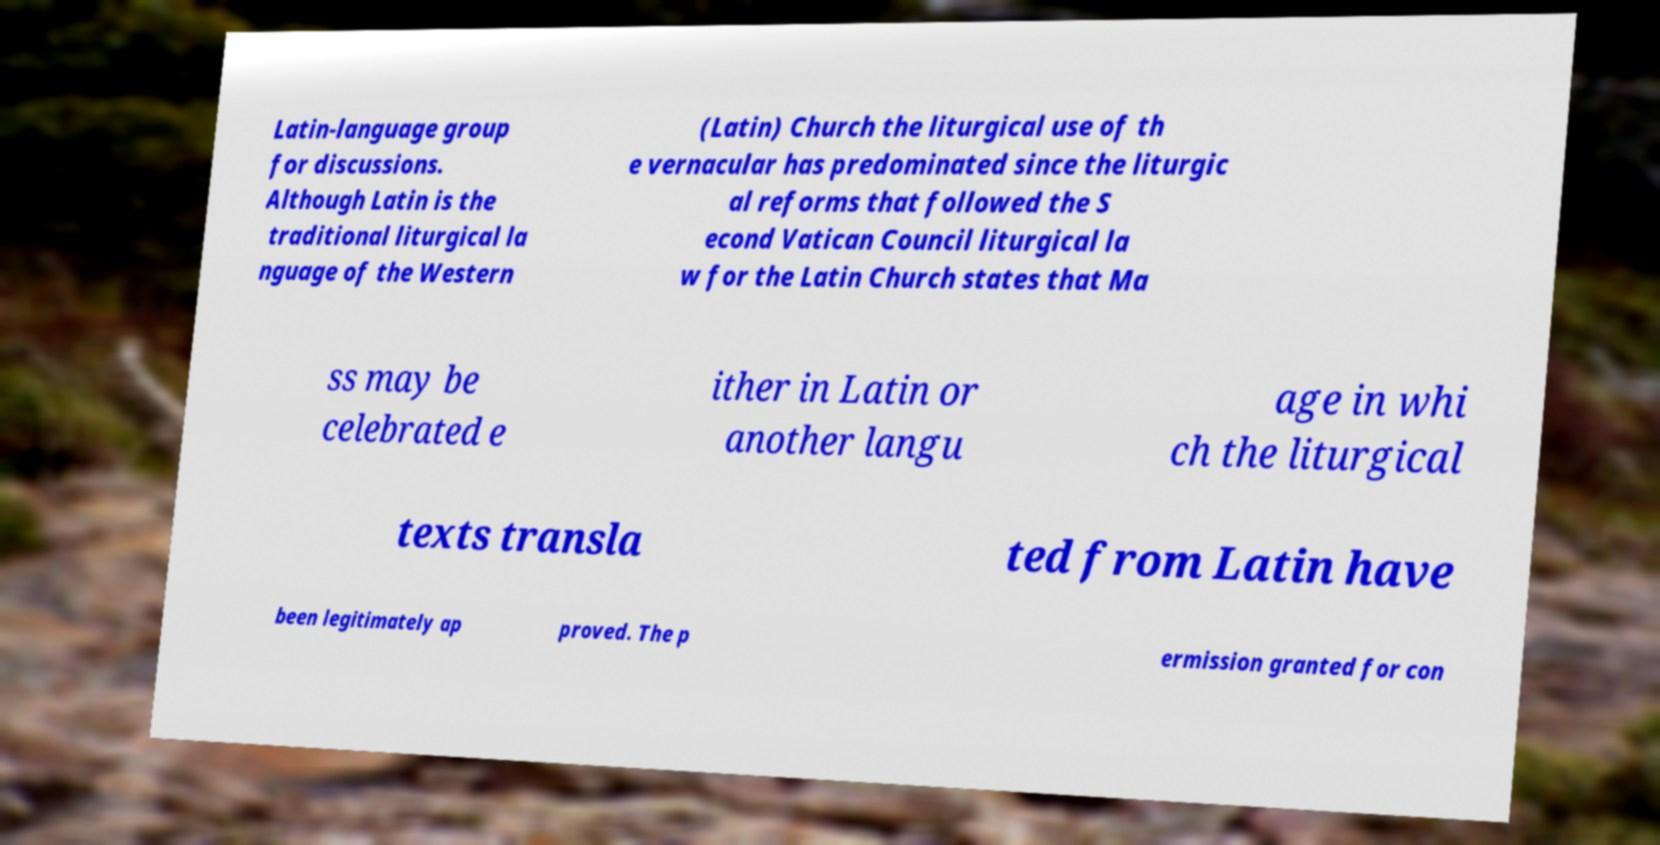Can you accurately transcribe the text from the provided image for me? Latin-language group for discussions. Although Latin is the traditional liturgical la nguage of the Western (Latin) Church the liturgical use of th e vernacular has predominated since the liturgic al reforms that followed the S econd Vatican Council liturgical la w for the Latin Church states that Ma ss may be celebrated e ither in Latin or another langu age in whi ch the liturgical texts transla ted from Latin have been legitimately ap proved. The p ermission granted for con 